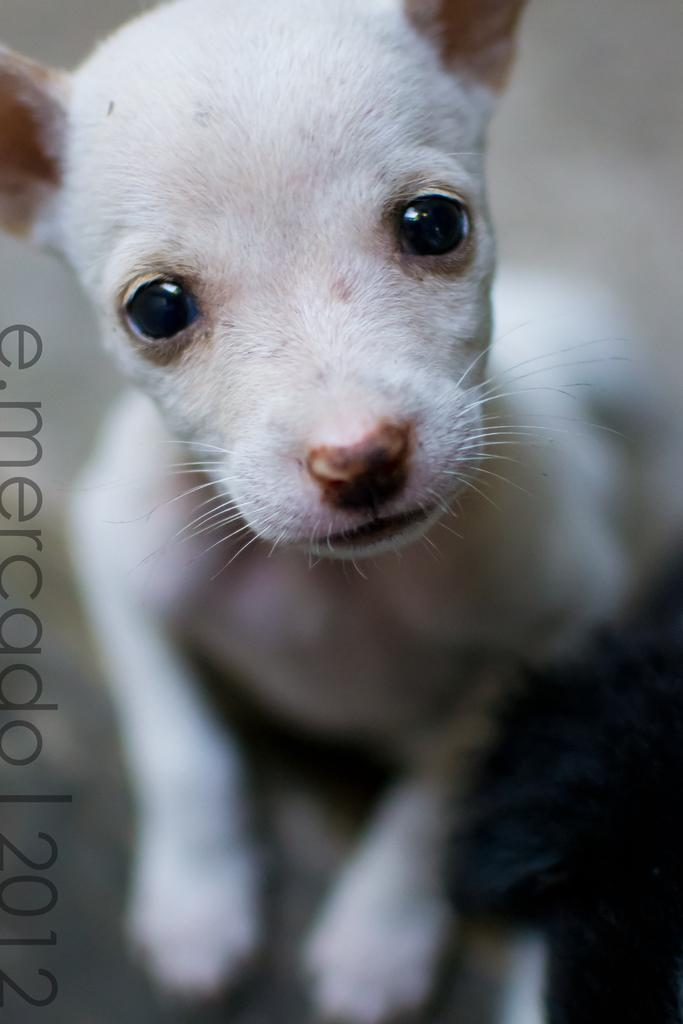What type of creature is present in the image? There is an animal in the image. What else can be seen in the image besides the animal? There is text in the image. Can you describe the background of the image? The background of the image is blurry. How many rings are visible on the animal's tail in the image? There are no rings visible on the animal's tail in the image, as the animal and text are the only subjects mentioned in the facts. 